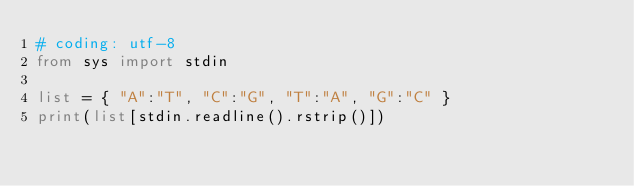<code> <loc_0><loc_0><loc_500><loc_500><_Python_># coding: utf-8
from sys import stdin

list = { "A":"T", "C":"G", "T":"A", "G":"C" }
print(list[stdin.readline().rstrip()])</code> 